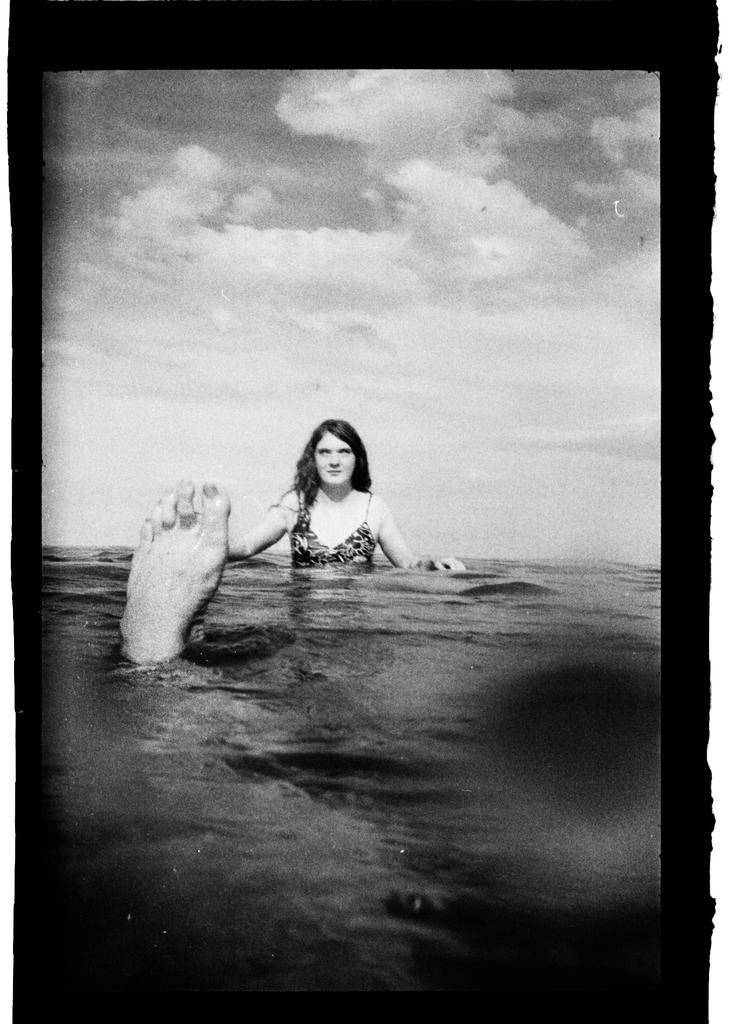What is the color scheme of the image? The image is black and white. Who is present in the image? There is a woman in the image. What part of a person's body is in the water? A person's leg is in the water. What can be seen in the background of the image? The sky is visible in the background of the image. What type of weather is suggested by the clouds in the sky? The presence of clouds in the sky suggests that it might be a partly cloudy day. What type of stamp can be seen on the woman's forehead in the image? There is no stamp present on the woman's forehead in the image. What company does the woman represent in the image? The image does not provide any information about the woman representing a company. 